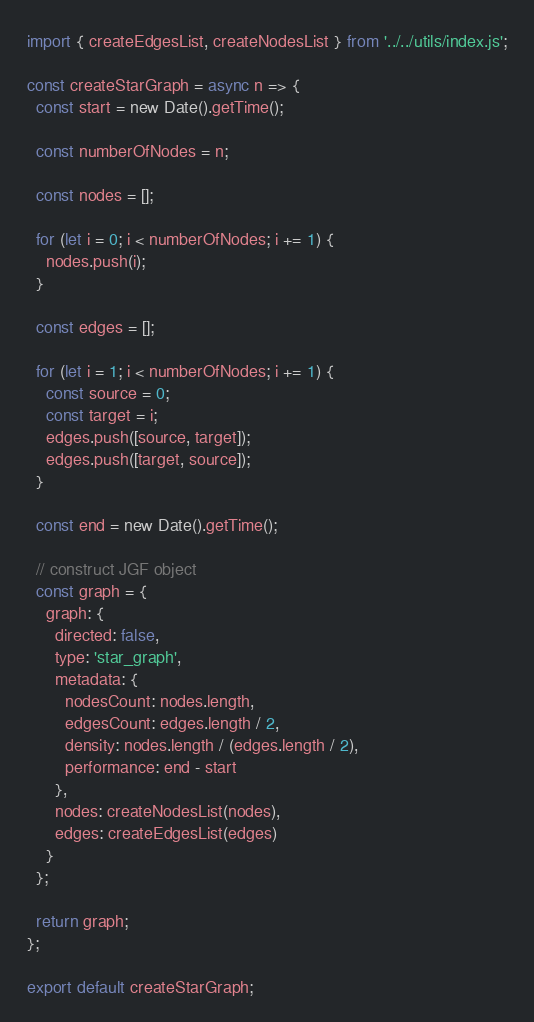<code> <loc_0><loc_0><loc_500><loc_500><_JavaScript_>import { createEdgesList, createNodesList } from '../../utils/index.js';

const createStarGraph = async n => {
  const start = new Date().getTime();

  const numberOfNodes = n;

  const nodes = [];

  for (let i = 0; i < numberOfNodes; i += 1) {
    nodes.push(i);
  }

  const edges = [];

  for (let i = 1; i < numberOfNodes; i += 1) {
    const source = 0;
    const target = i;
    edges.push([source, target]);
    edges.push([target, source]);
  }

  const end = new Date().getTime();

  // construct JGF object
  const graph = {
    graph: {
      directed: false,
      type: 'star_graph',
      metadata: {
        nodesCount: nodes.length,
        edgesCount: edges.length / 2,
        density: nodes.length / (edges.length / 2),
        performance: end - start
      },
      nodes: createNodesList(nodes),
      edges: createEdgesList(edges)
    }
  };

  return graph;
};

export default createStarGraph;
</code> 